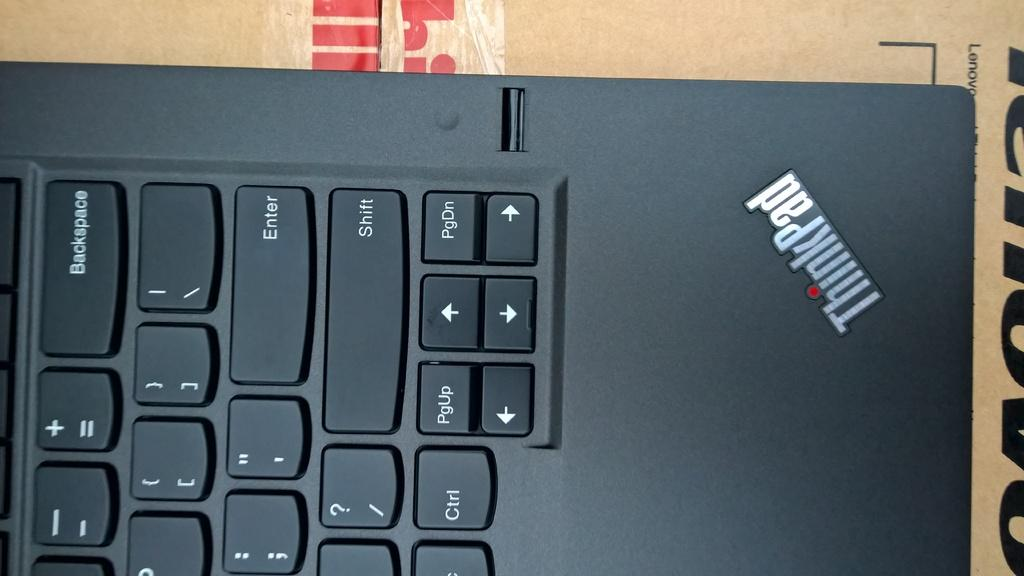<image>
Relay a brief, clear account of the picture shown. A computer keyboard displays the name ThinkPad in the corner. 